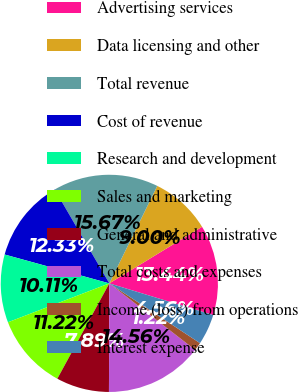Convert chart. <chart><loc_0><loc_0><loc_500><loc_500><pie_chart><fcel>Advertising services<fcel>Data licensing and other<fcel>Total revenue<fcel>Cost of revenue<fcel>Research and development<fcel>Sales and marketing<fcel>General and administrative<fcel>Total costs and expenses<fcel>Income (loss) from operations<fcel>Interest expense<nl><fcel>13.44%<fcel>9.0%<fcel>15.67%<fcel>12.33%<fcel>10.11%<fcel>11.22%<fcel>7.89%<fcel>14.56%<fcel>1.22%<fcel>4.56%<nl></chart> 